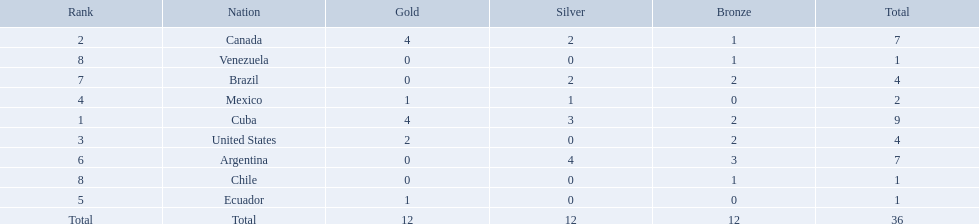Which countries have won gold medals? Cuba, Canada, United States, Mexico, Ecuador. Of these countries, which ones have never won silver or bronze medals? United States, Ecuador. Of the two nations listed previously, which one has only won a gold medal? Ecuador. What were the amounts of bronze medals won by the countries? 2, 1, 2, 0, 0, 3, 2, 1, 1. Which is the highest? 3. Which nation had this amount? Argentina. 